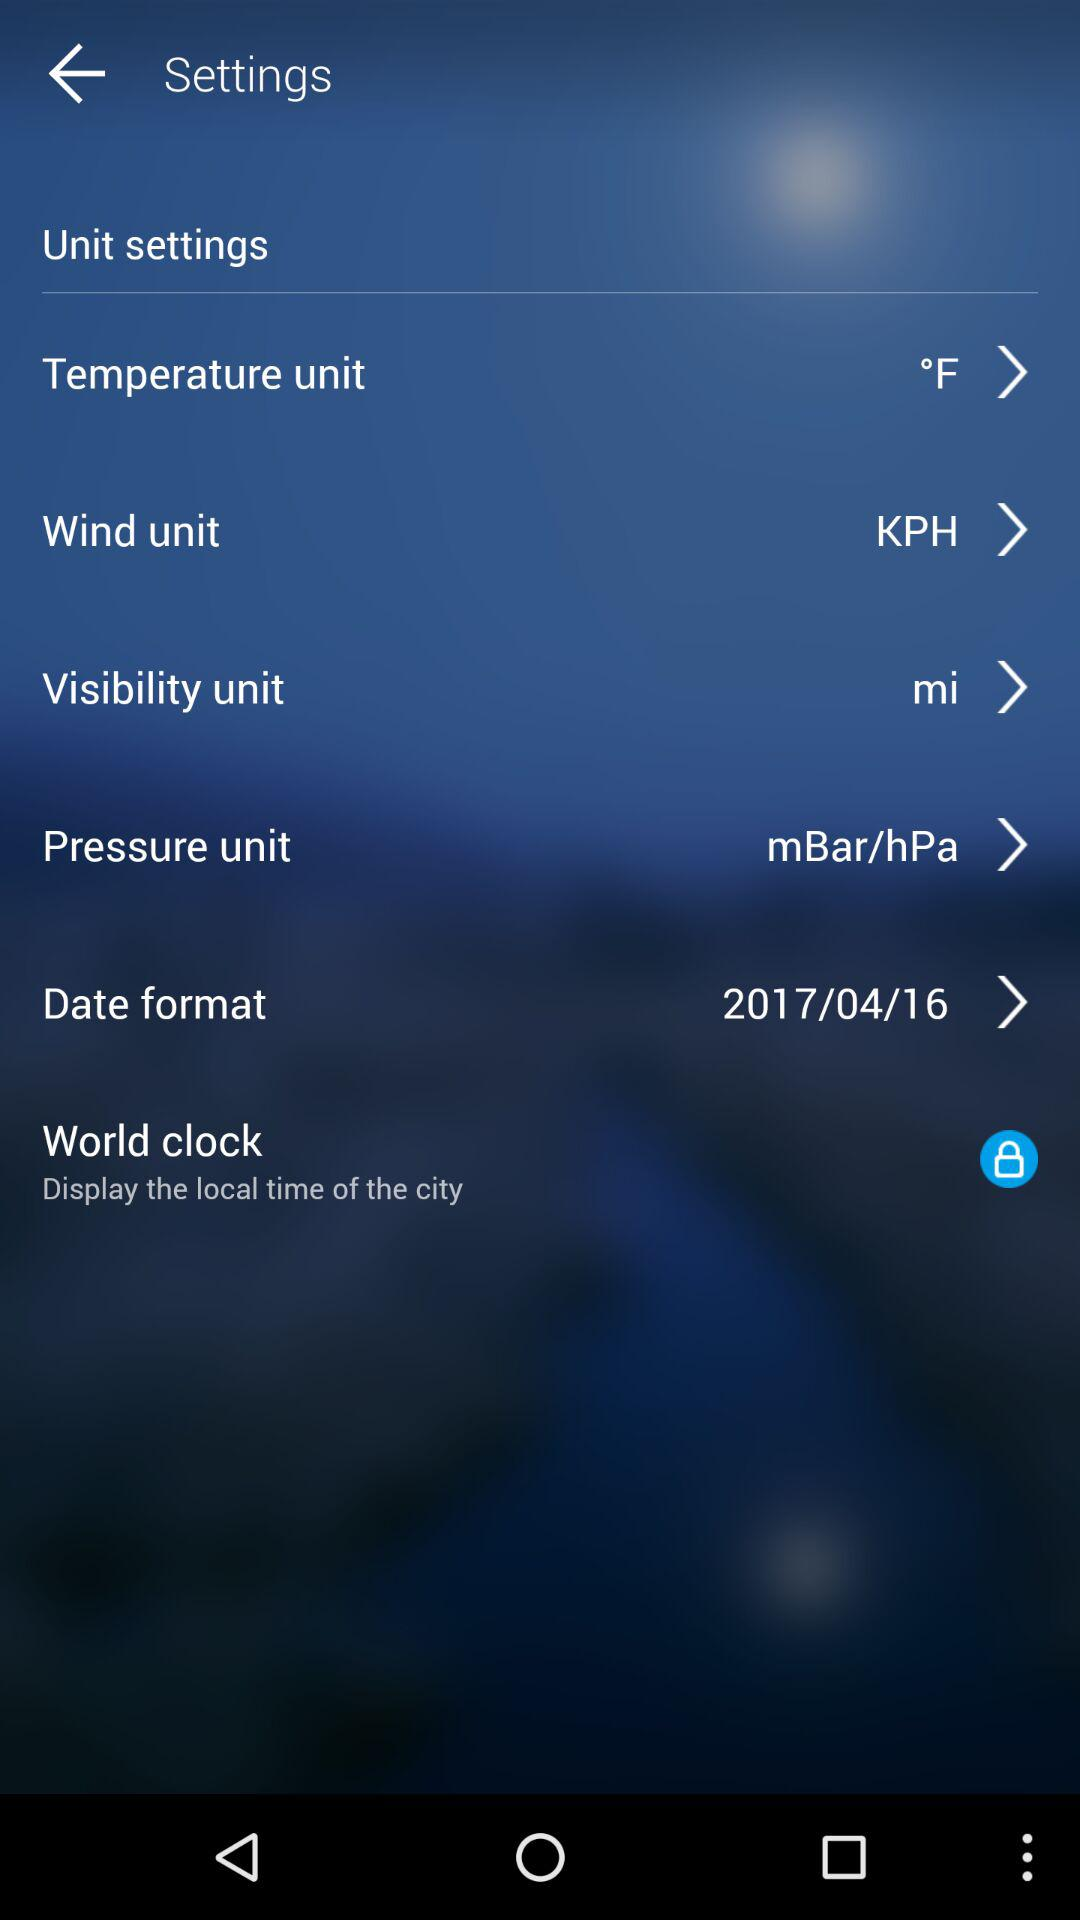How many settings are available?
Answer the question using a single word or phrase. 6 